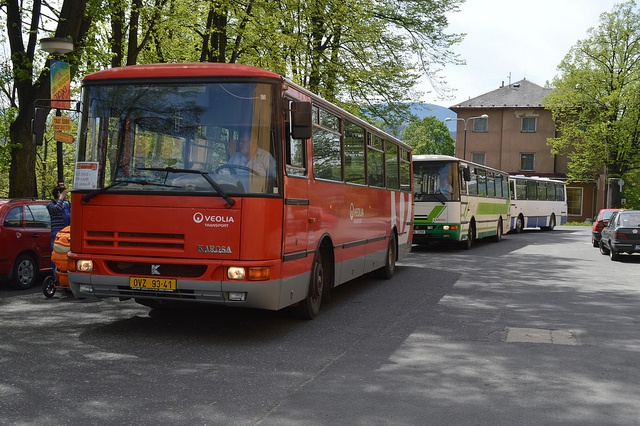Describe the objects in this image and their specific colors. I can see bus in lavender, black, brown, gray, and maroon tones, bus in lavender, black, gray, darkgray, and darkgreen tones, car in lavender, black, maroon, gray, and darkgray tones, bus in lavender, darkgray, gray, black, and darkgreen tones, and car in lavender, black, darkgray, gray, and lightgray tones in this image. 